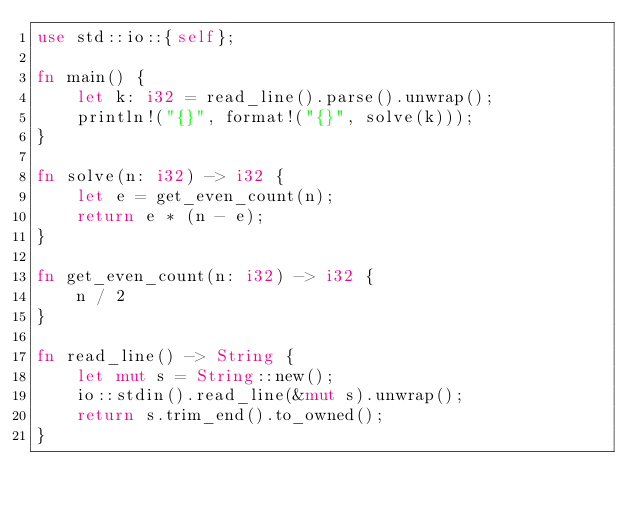<code> <loc_0><loc_0><loc_500><loc_500><_Rust_>use std::io::{self};

fn main() {
    let k: i32 = read_line().parse().unwrap();
    println!("{}", format!("{}", solve(k)));
}

fn solve(n: i32) -> i32 {
    let e = get_even_count(n);
    return e * (n - e);
}

fn get_even_count(n: i32) -> i32 {
    n / 2
}

fn read_line() -> String {
    let mut s = String::new();
    io::stdin().read_line(&mut s).unwrap();
    return s.trim_end().to_owned();
}</code> 